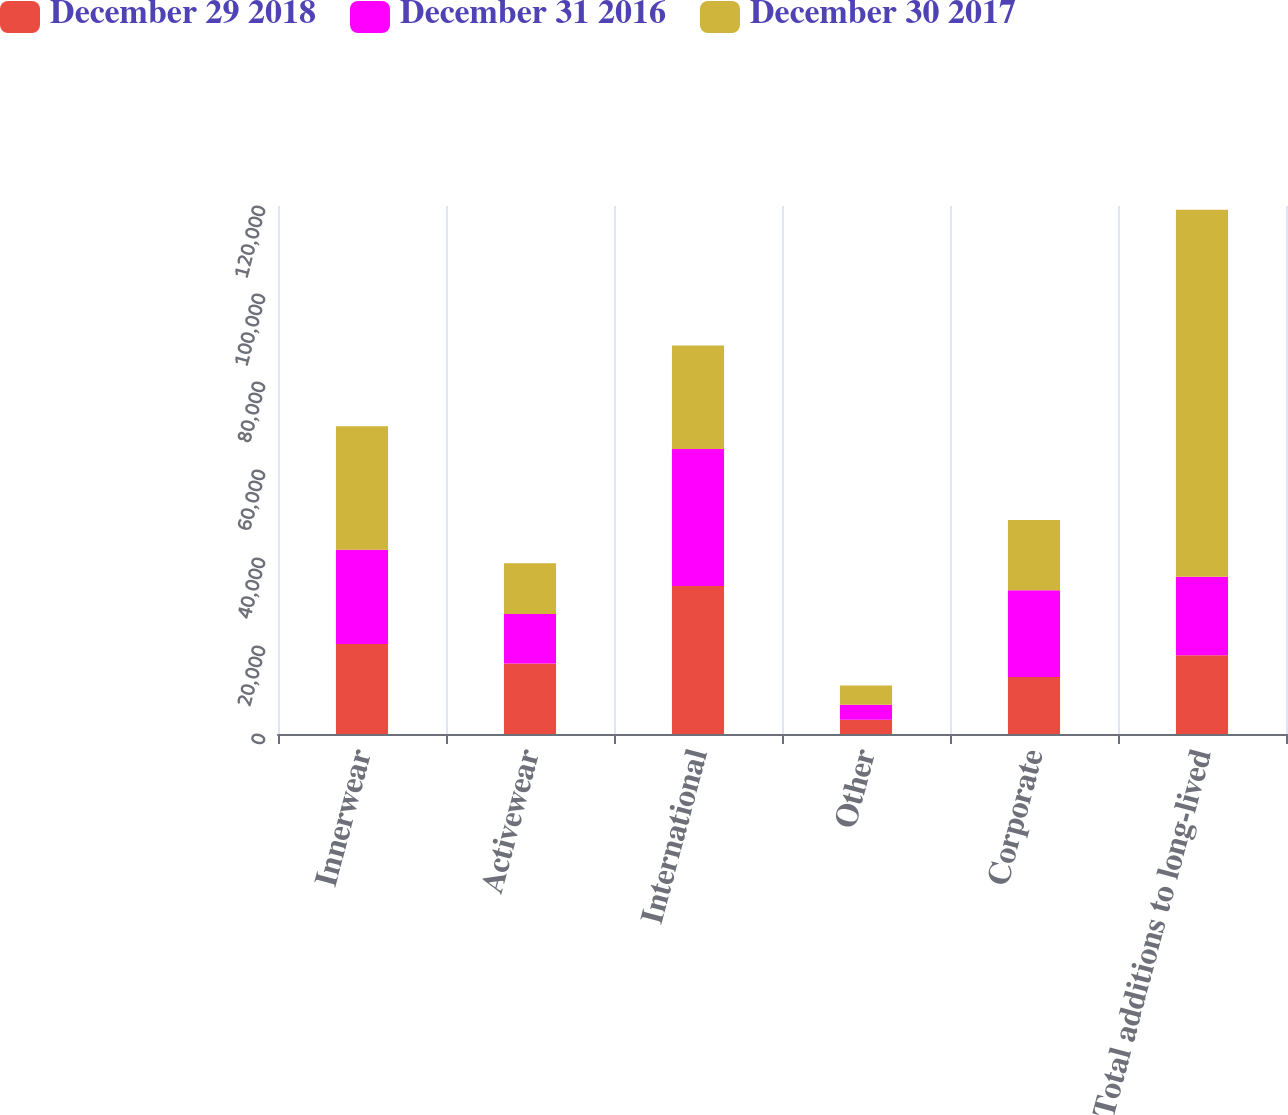Convert chart to OTSL. <chart><loc_0><loc_0><loc_500><loc_500><stacked_bar_chart><ecel><fcel>Innerwear<fcel>Activewear<fcel>International<fcel>Other<fcel>Corporate<fcel>Total additions to long-lived<nl><fcel>December 29 2018<fcel>20459<fcel>16024<fcel>33632<fcel>3221<fcel>12957<fcel>17880<nl><fcel>December 31 2016<fcel>21427<fcel>11263<fcel>31127<fcel>3455<fcel>19736<fcel>17880<nl><fcel>December 30 2017<fcel>28078<fcel>11518<fcel>23520<fcel>4353<fcel>15930<fcel>83399<nl></chart> 